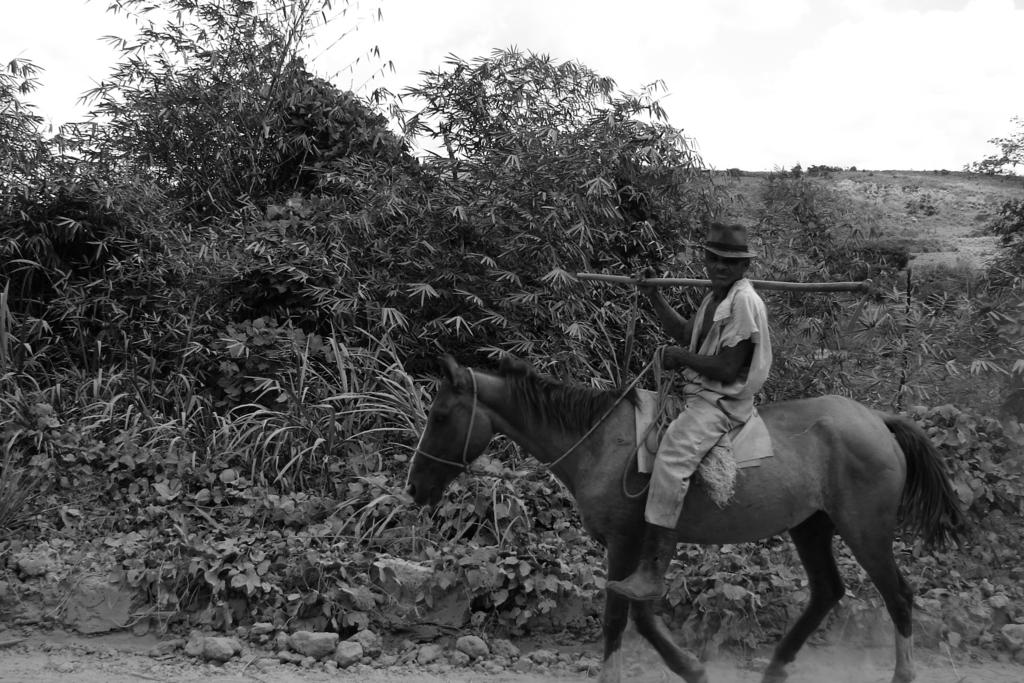What is the person in the image doing? The person is sitting on a horse. What object is the person holding? The person is holding a stick. What can be seen in the background of the image? There are trees and plants in the background of the image. What type of zinc is present in the image? There is no zinc present in the image. How many sisters are visible in the image? There are no sisters present in the image. 